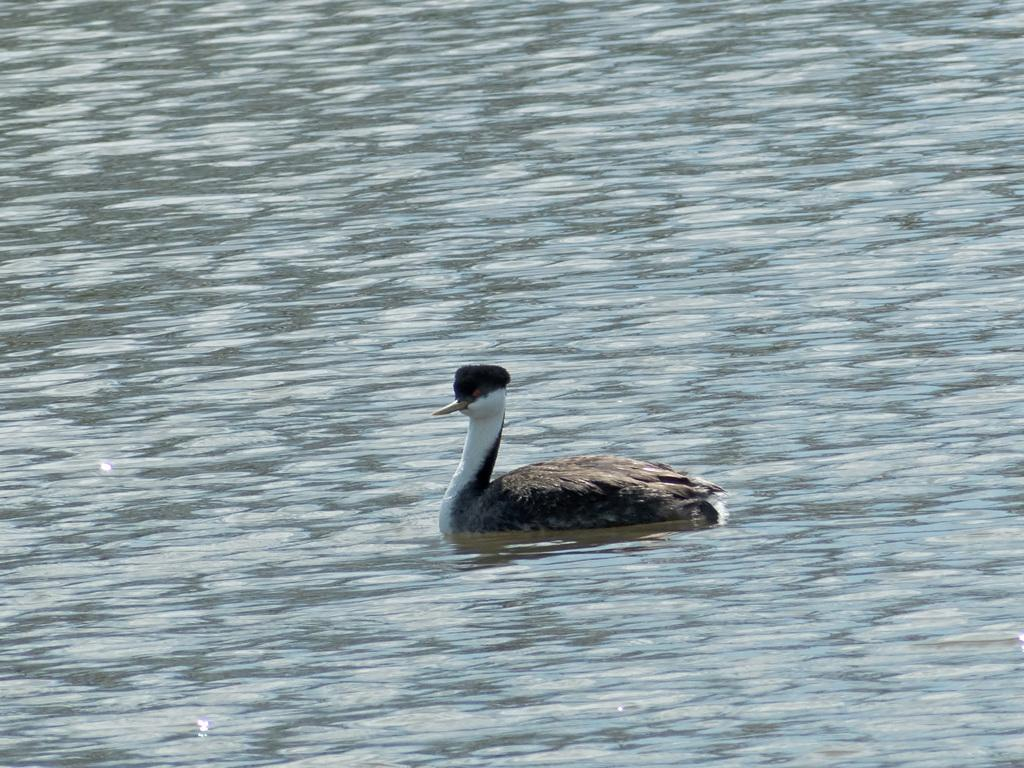What type of bird can be seen in the image? A western grebe is present in the image. What is the western grebe doing in the image? The western grebe is swimming on the water. What type of sign can be seen in the image? There is no sign present in the image; it features a western grebe swimming on the water. What company might be associated with the western grebe in the image? The image does not depict any company or brand; it simply shows a western grebe swimming on the water. 